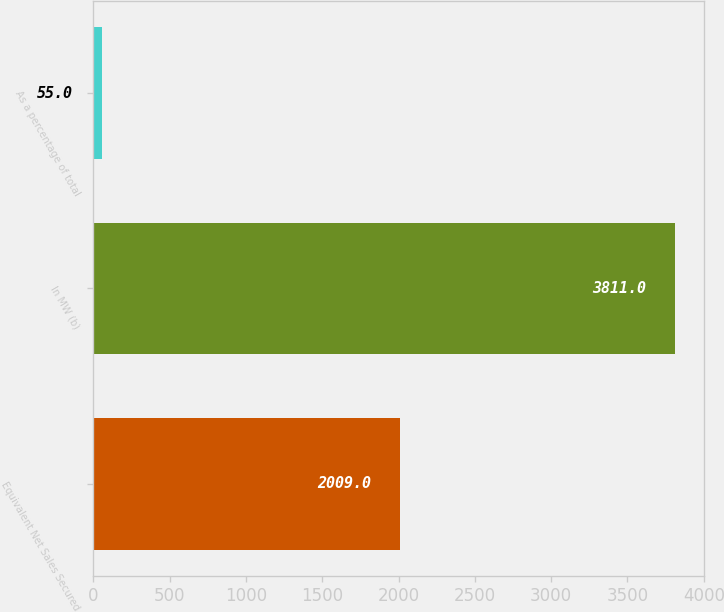Convert chart to OTSL. <chart><loc_0><loc_0><loc_500><loc_500><bar_chart><fcel>Equivalent Net Sales Secured<fcel>In MW (b)<fcel>As a percentage of total<nl><fcel>2009<fcel>3811<fcel>55<nl></chart> 